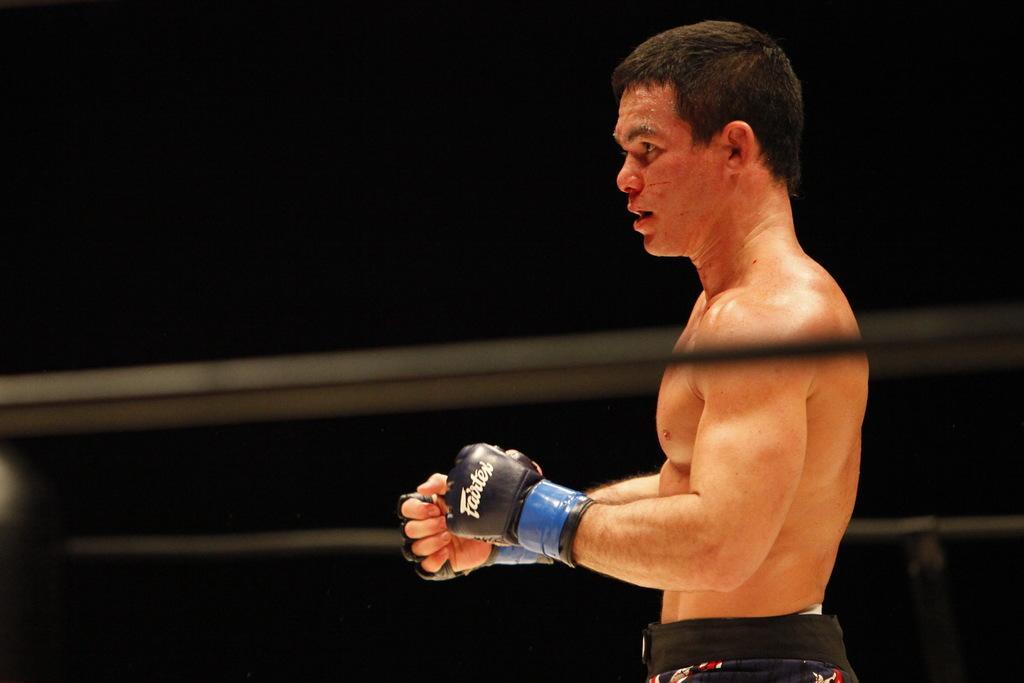How would you summarize this image in a sentence or two? In this image I can see a person wearing black color gloves and I can see dark background. 